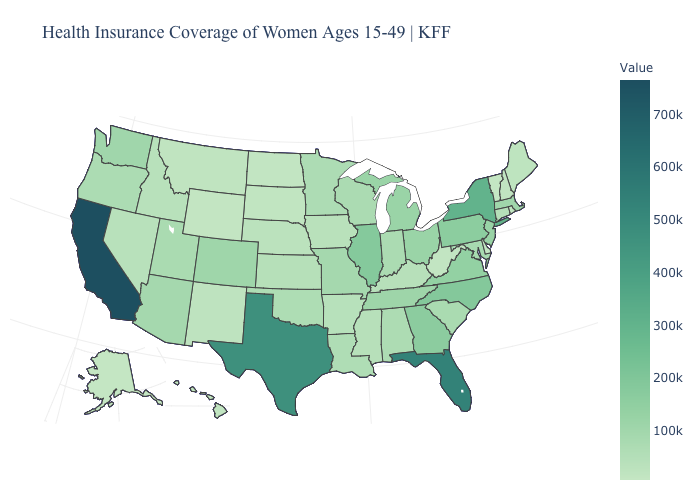Does Iowa have the highest value in the MidWest?
Quick response, please. No. Is the legend a continuous bar?
Quick response, please. Yes. Is the legend a continuous bar?
Quick response, please. Yes. Does Florida have a higher value than Virginia?
Concise answer only. Yes. Does the map have missing data?
Keep it brief. No. 